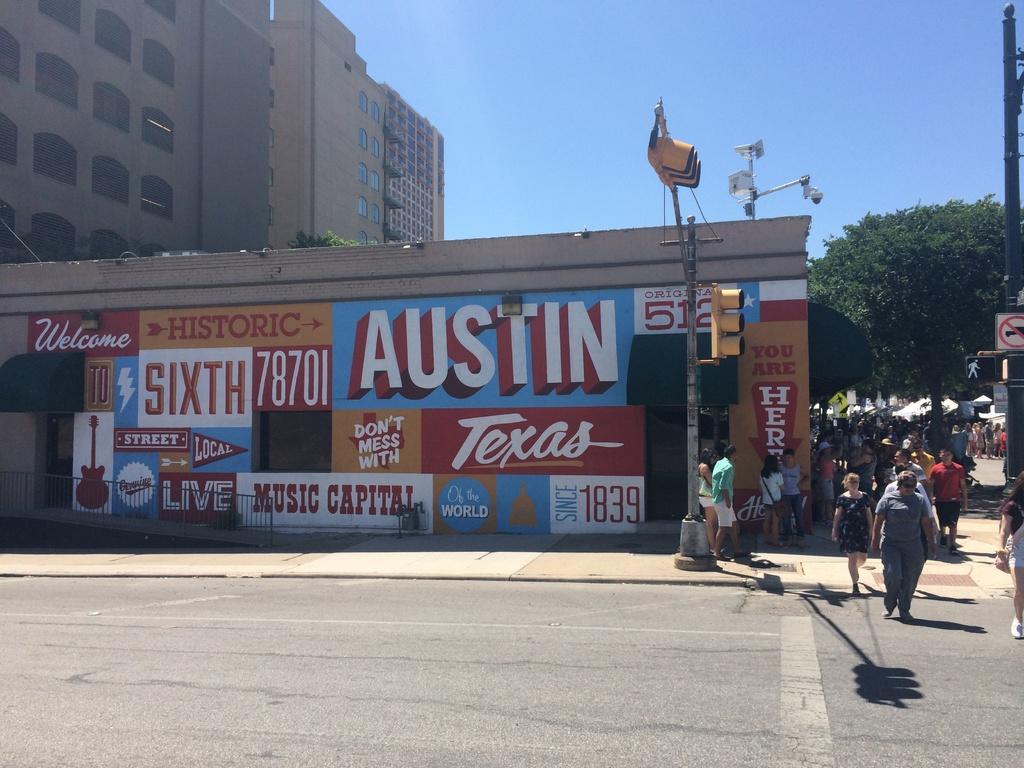Could you give a brief overview of what you see in this image? This picture is clicked outside. On the left we can see the buildings and the traffic lights and street lights are attached to the poles and we can see the group of persons seems to be walking on the ground. In the background we can see the sky, trees and some objects attached to the pole and we can see the text on the building. 